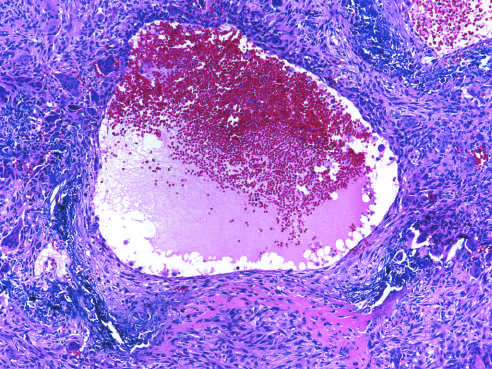s the aneurysmal bone cyst with blood-filled cystic space surrounded by a fibrous wall containing proliferating fibroblasts, reactive woven bone, and osteoclast-type giant cells?
Answer the question using a single word or phrase. Yes 